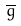<formula> <loc_0><loc_0><loc_500><loc_500>\overline { g }</formula> 